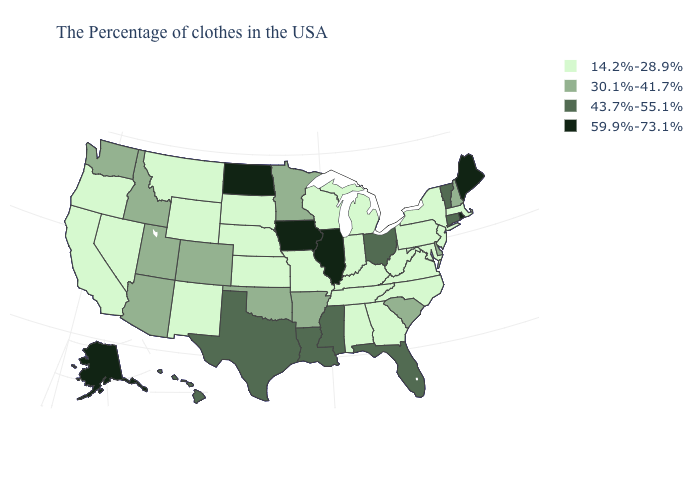What is the value of Texas?
Short answer required. 43.7%-55.1%. Among the states that border Maryland , which have the lowest value?
Answer briefly. Pennsylvania, Virginia, West Virginia. What is the value of Texas?
Be succinct. 43.7%-55.1%. Does Iowa have the highest value in the MidWest?
Answer briefly. Yes. Does Virginia have the same value as Oklahoma?
Be succinct. No. Does the map have missing data?
Quick response, please. No. Does Mississippi have a lower value than Alaska?
Answer briefly. Yes. Name the states that have a value in the range 14.2%-28.9%?
Be succinct. Massachusetts, New York, New Jersey, Maryland, Pennsylvania, Virginia, North Carolina, West Virginia, Georgia, Michigan, Kentucky, Indiana, Alabama, Tennessee, Wisconsin, Missouri, Kansas, Nebraska, South Dakota, Wyoming, New Mexico, Montana, Nevada, California, Oregon. Name the states that have a value in the range 30.1%-41.7%?
Be succinct. New Hampshire, Delaware, South Carolina, Arkansas, Minnesota, Oklahoma, Colorado, Utah, Arizona, Idaho, Washington. What is the lowest value in the South?
Write a very short answer. 14.2%-28.9%. Does Illinois have the lowest value in the MidWest?
Keep it brief. No. What is the lowest value in the South?
Give a very brief answer. 14.2%-28.9%. What is the value of Hawaii?
Concise answer only. 43.7%-55.1%. Which states have the lowest value in the Northeast?
Short answer required. Massachusetts, New York, New Jersey, Pennsylvania. What is the lowest value in states that border Wisconsin?
Be succinct. 14.2%-28.9%. 